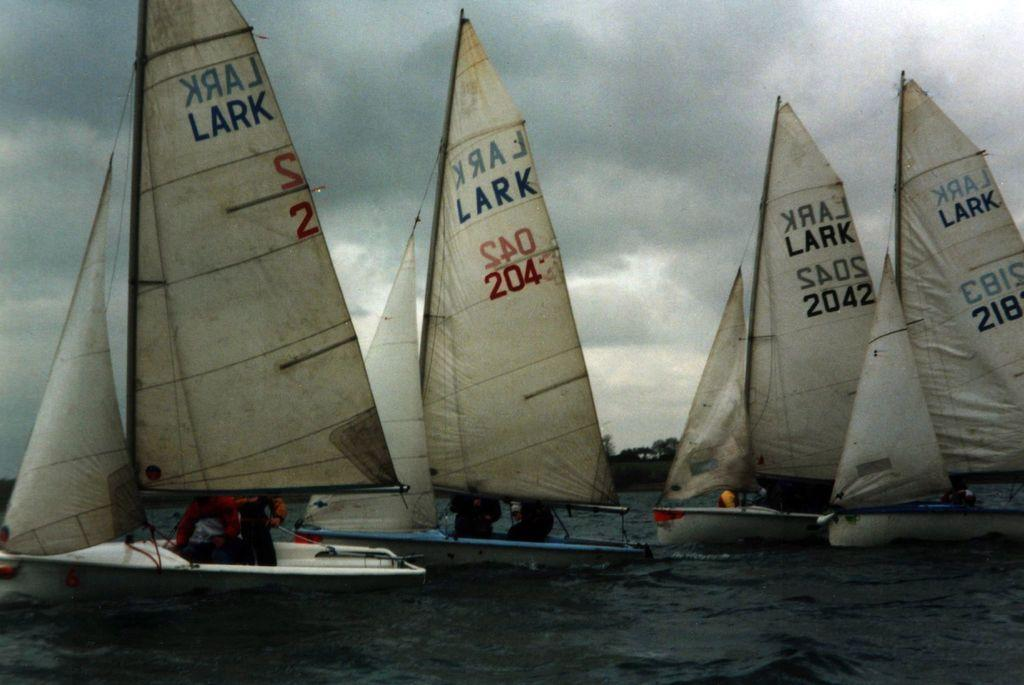What is depicted in the image? There are boats in the image. Where are the boats located? The boats are on the water. Are there any people in the boats? Yes, there are people in the boats. What can be seen in the background of the image? There are trees and clouds in the sky in the background of the image. What part of the natural environment is visible in the image? The sky is visible in the background of the image. What type of liquid can be seen flowing out of the hospital in the image? There is no hospital present in the image, and therefore no liquid flowing out of it. 